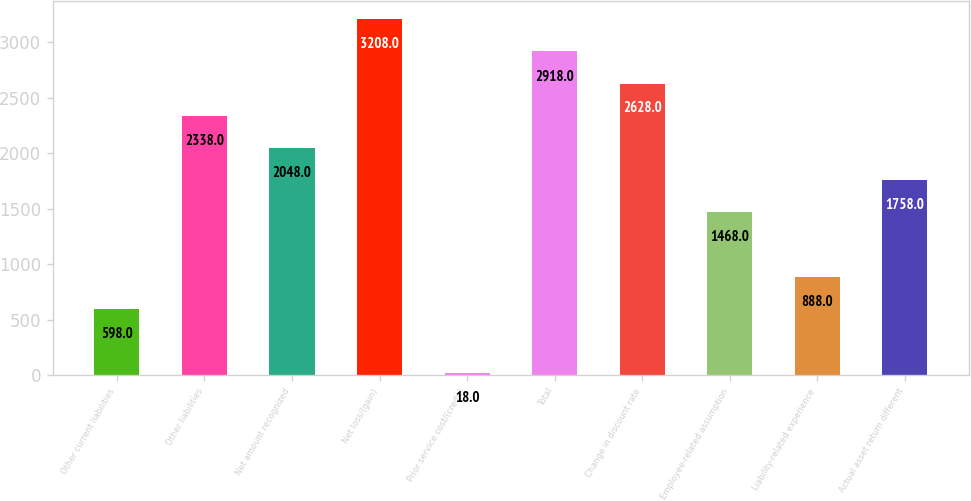Convert chart to OTSL. <chart><loc_0><loc_0><loc_500><loc_500><bar_chart><fcel>Other current liabilities<fcel>Other liabilities<fcel>Net amount recognized<fcel>Net loss/(gain)<fcel>Prior service cost/(credit)<fcel>Total<fcel>Change in discount rate<fcel>Employee-related assumption<fcel>Liability-related experience<fcel>Actual asset return different<nl><fcel>598<fcel>2338<fcel>2048<fcel>3208<fcel>18<fcel>2918<fcel>2628<fcel>1468<fcel>888<fcel>1758<nl></chart> 